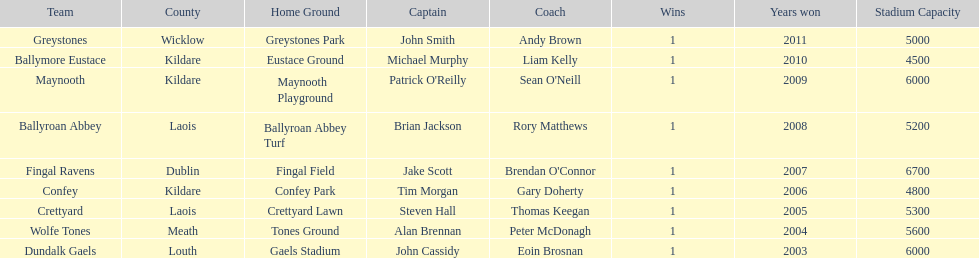What is the total of wins on the chart 9. 